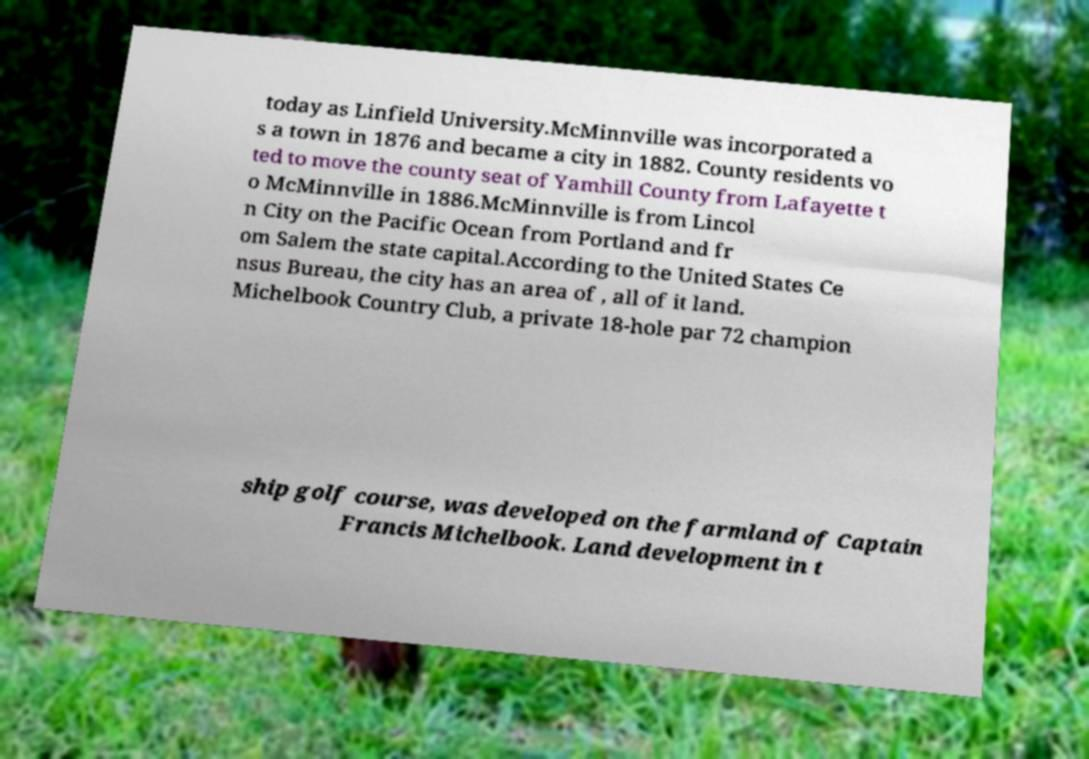Can you read and provide the text displayed in the image?This photo seems to have some interesting text. Can you extract and type it out for me? today as Linfield University.McMinnville was incorporated a s a town in 1876 and became a city in 1882. County residents vo ted to move the county seat of Yamhill County from Lafayette t o McMinnville in 1886.McMinnville is from Lincol n City on the Pacific Ocean from Portland and fr om Salem the state capital.According to the United States Ce nsus Bureau, the city has an area of , all of it land. Michelbook Country Club, a private 18-hole par 72 champion ship golf course, was developed on the farmland of Captain Francis Michelbook. Land development in t 